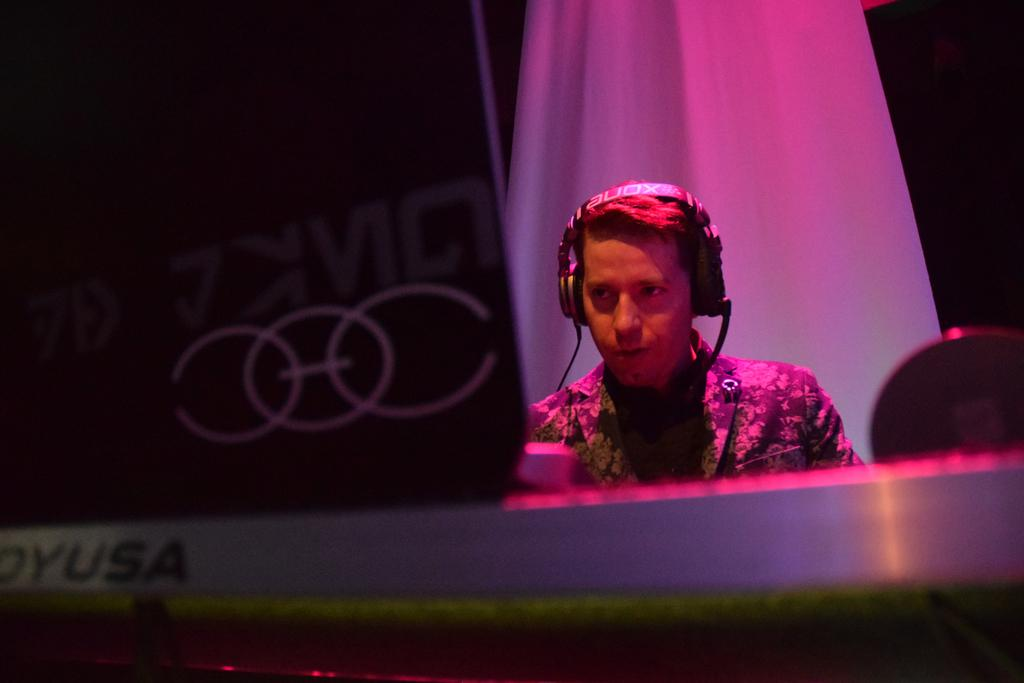What can be seen in the image? There is a person in the image. Can you describe the person's attire? The person is wearing clothes and a headset. What is located on the left side of the image? There is an object on the left side of the image. How many mittens can be seen on the person's hands in the image? There are no mittens present in the image; the person is wearing a headset. What type of cover is protecting the person from the elements in the image? The image does not show any cover protecting the person from the elements. 